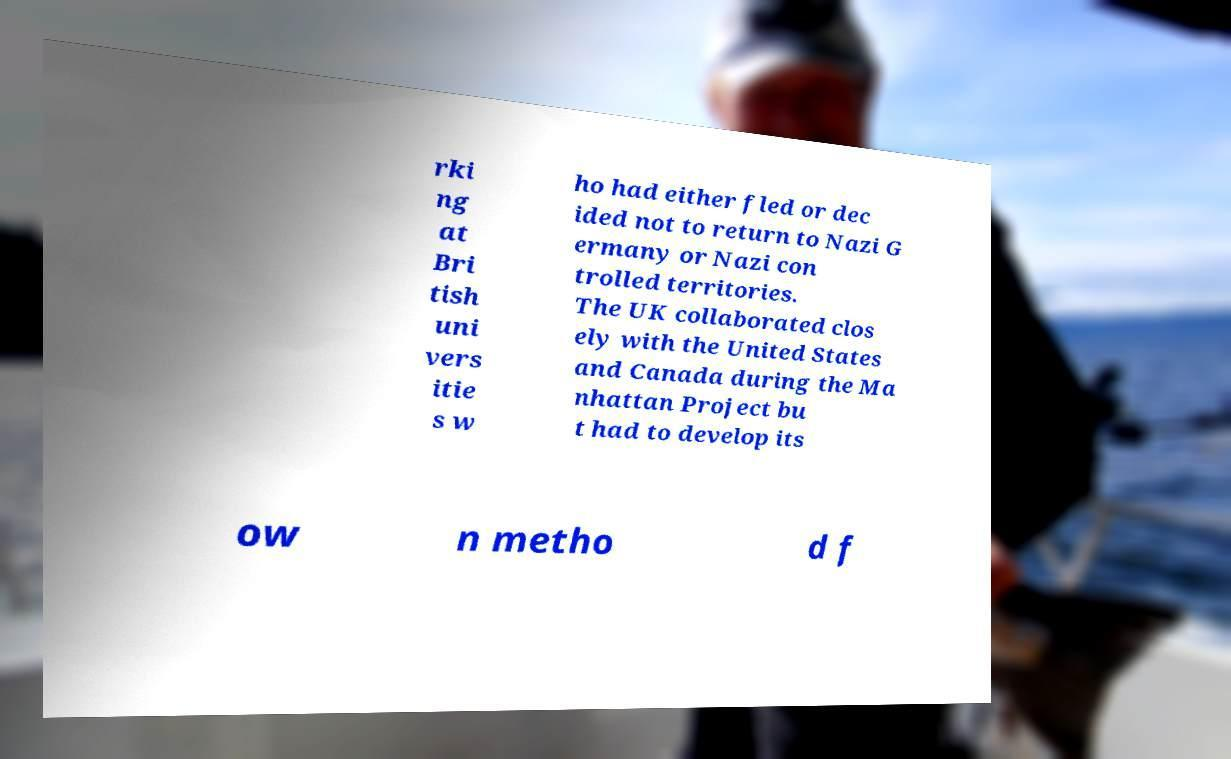Please read and relay the text visible in this image. What does it say? rki ng at Bri tish uni vers itie s w ho had either fled or dec ided not to return to Nazi G ermany or Nazi con trolled territories. The UK collaborated clos ely with the United States and Canada during the Ma nhattan Project bu t had to develop its ow n metho d f 